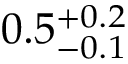<formula> <loc_0><loc_0><loc_500><loc_500>0 . 5 _ { - 0 . 1 } ^ { + 0 . 2 }</formula> 